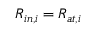Convert formula to latex. <formula><loc_0><loc_0><loc_500><loc_500>R _ { i n , i } = R _ { a t , i }</formula> 